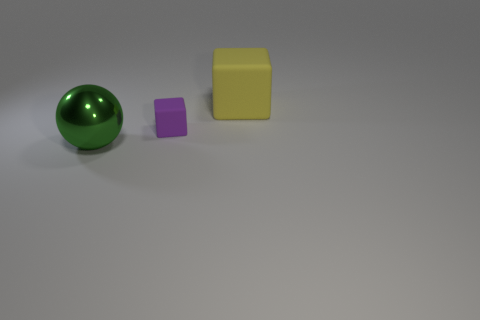Add 3 small cubes. How many objects exist? 6 Subtract all purple blocks. How many blocks are left? 1 Subtract all cubes. How many objects are left? 1 Subtract 1 cubes. How many cubes are left? 1 Subtract all yellow spheres. How many purple blocks are left? 1 Subtract all small gray metallic objects. Subtract all balls. How many objects are left? 2 Add 3 large yellow matte cubes. How many large yellow matte cubes are left? 4 Add 1 tiny cyan shiny objects. How many tiny cyan shiny objects exist? 1 Subtract 0 brown balls. How many objects are left? 3 Subtract all cyan cubes. Subtract all purple balls. How many cubes are left? 2 